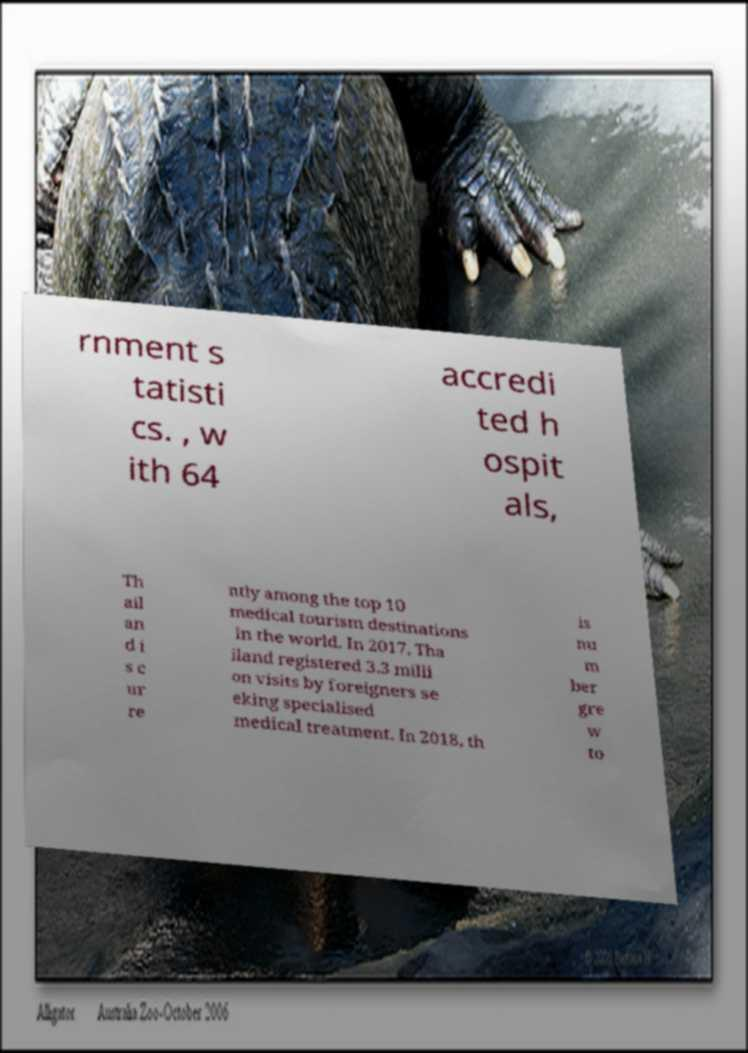Please identify and transcribe the text found in this image. rnment s tatisti cs. , w ith 64 accredi ted h ospit als, Th ail an d i s c ur re ntly among the top 10 medical tourism destinations in the world. In 2017, Tha iland registered 3.3 milli on visits by foreigners se eking specialised medical treatment. In 2018, th is nu m ber gre w to 